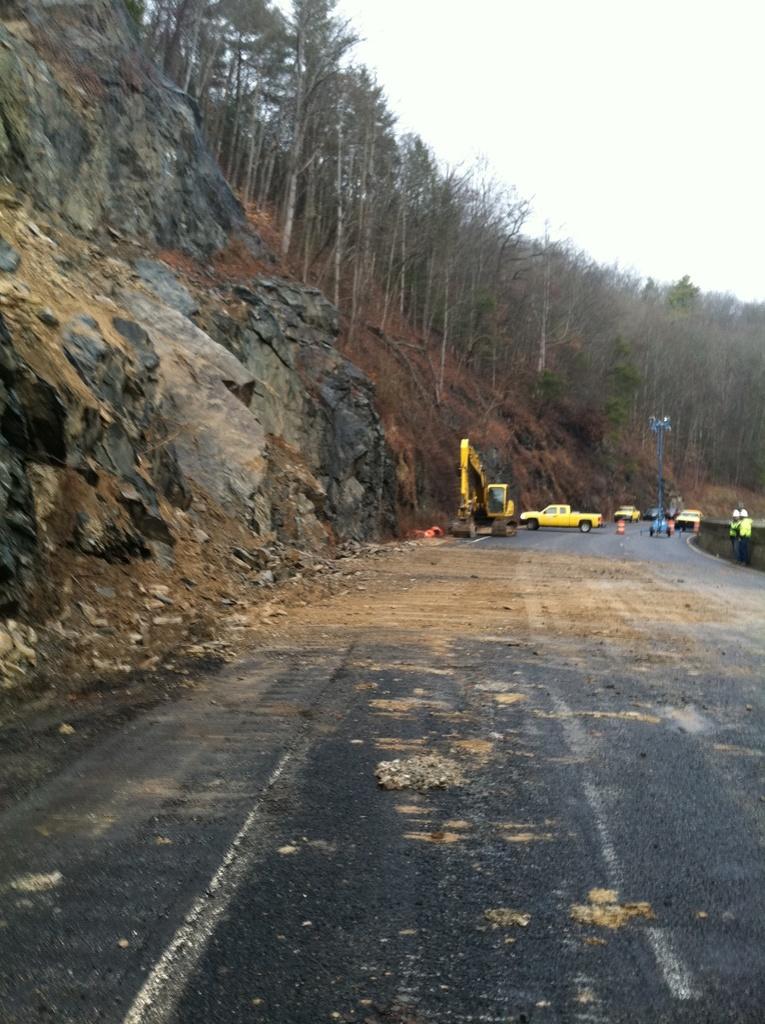How would you summarize this image in a sentence or two? At the bottom of the image I can see the road. In the background there are some cars and bulldozer. Beside the road two persons are standing. On the left side I can see a rock and many trees. At the top of the image I can see the sky. 